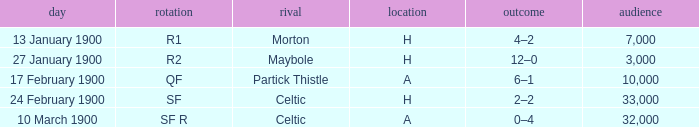What round did the celtic played away on 24 february 1900? SF. 